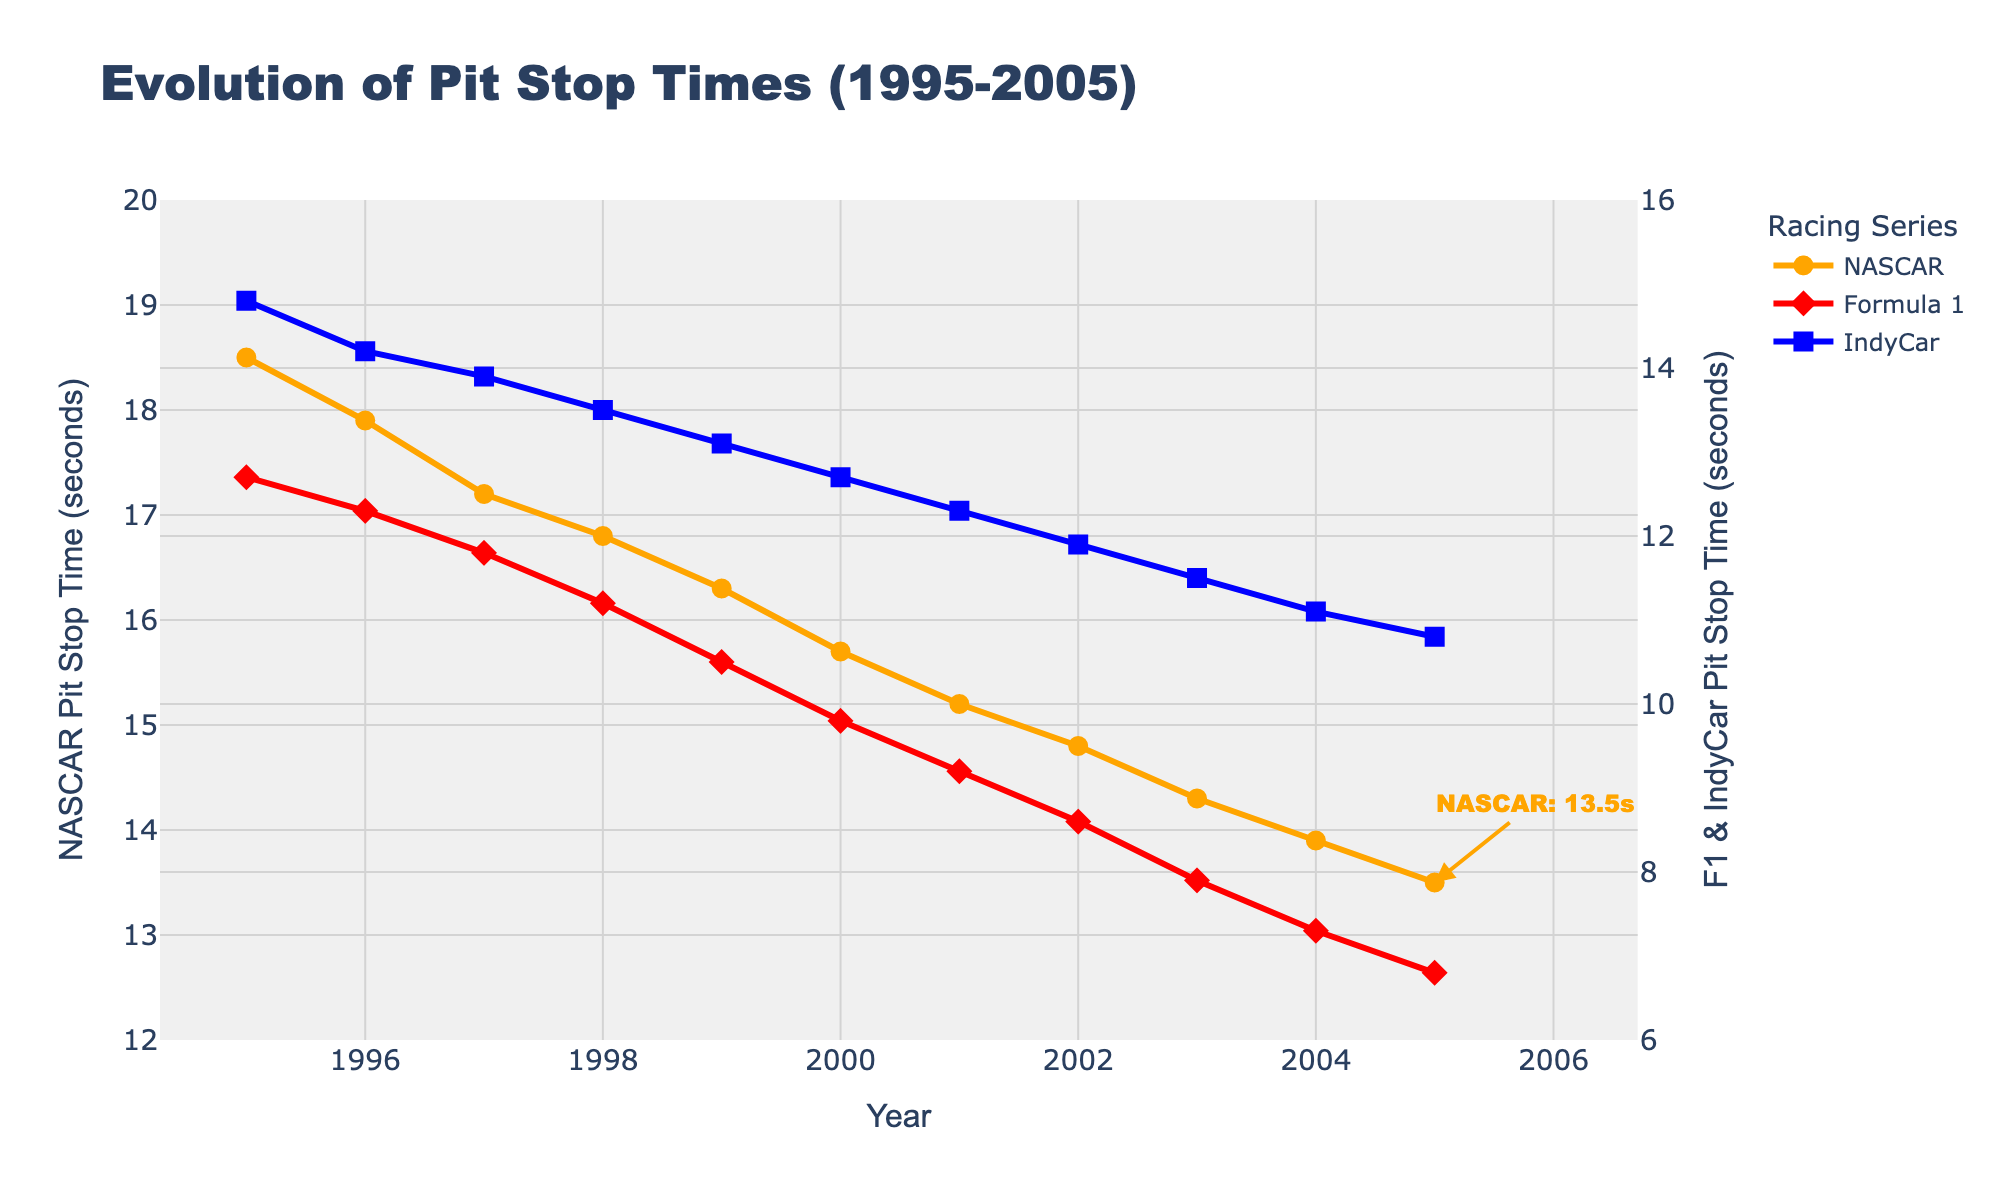What year did NASCAR have a pit stop time of 16.8 seconds? To find the specific year when NASCAR had a 16.8-second pit stop, look at the NASCAR line and find the corresponding year where the value is 16.8 seconds.
Answer: 1998 Which racing series showed the greatest decrease in pit stop times from 1995 to 2005? To determine which series showed the greatest decrease, calculate the difference in pit stop times from 1995 to 2005 for each series and compare them. NASCAR: 18.5 - 13.5 = 5 seconds decrease, Formula 1: 12.7 - 6.8 = 5.9 seconds decrease, IndyCar: 14.8 - 10.8 = 4 seconds decrease. Formula 1 had the greatest decrease.
Answer: Formula 1 What was the average pit stop time for IndyCar in the years 2000 and 2001 combined? Find the pit stop times for IndyCar in 2000 and 2001 and calculate their average. (12.7 + 12.3) / 2 = 12.5 seconds.
Answer: 12.5 seconds In what year did Formula 1 pit stops drop below 10 seconds? To find the year when Formula 1 pit stops dropped below 10 seconds, look at the Formula 1 line and find the first year where the value is less than 10 seconds.
Answer: 2000 How much faster were Formula 1 pit stops in 2005 compared to NASCAR pit stops in the same year? Compare the pit stop times of Formula 1 and NASCAR in 2005 and calculate the difference. 13.5 - 6.8 = 6.7 seconds. Formula 1 was 6.7 seconds faster.
Answer: 6.7 seconds Which series had the smallest change in pit stop times between 1999 and 2002? Calculate the difference in pit stop times for each series between 1999 and 2002. NASCAR: 16.3 - 14.8 = 1.5 seconds decrease, Formula 1: 10.5 - 8.6 = 1.9 seconds decrease, IndyCar: 13.1 - 11.9 = 1.2 seconds decrease. IndyCar had the smallest change with a 1.2 seconds decrease.
Answer: IndyCar How did the trend of pit stop times for NASCAR and IndyCar compare over the entire period from 1995 to 2005? Both NASCAR and IndyCar showed a decreasing trend in pit stop times over the period from 1995 to 2005. Specifically, NASCAR decreased from 18.5 seconds to 13.5 seconds, and IndyCar decreased from 14.8 seconds to 10.8 seconds.
Answer: Both decreased What was the median pit stop time for NASCAR from 1995 to 2005? List the NASCAR pit stop times in order and find the middle value. Ordered times: 13.5, 13.9, 14.3, 14.8, 15.2, 15.7, 16.3, 16.8, 17.2, 17.9, 18.5. The median value is the sixth number in the ordered list, which is 15.7 seconds.
Answer: 15.7 seconds 